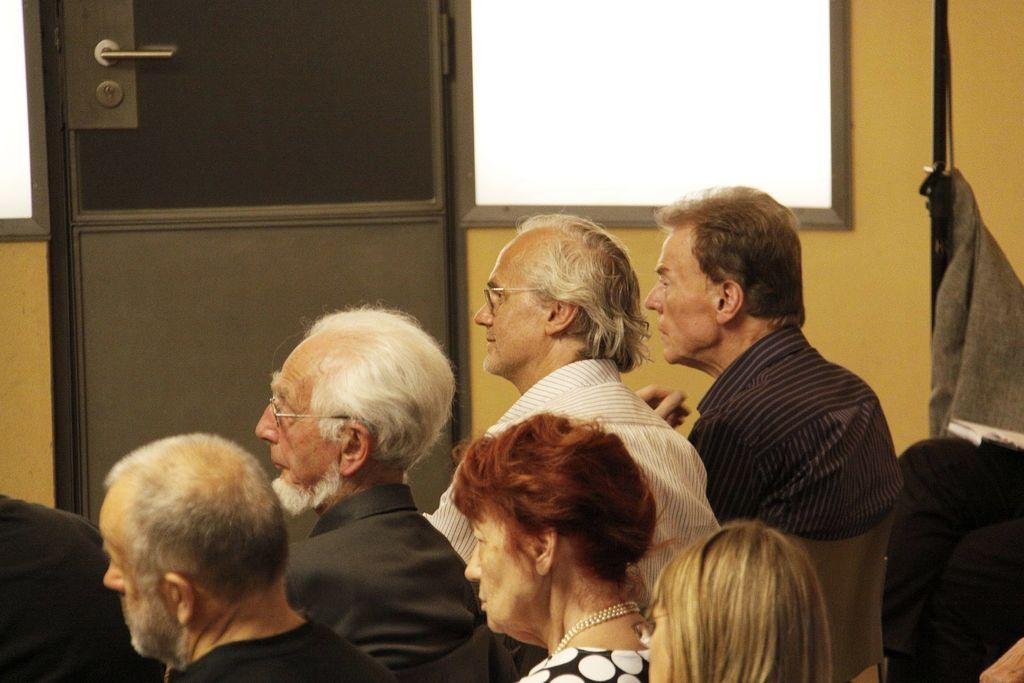What are the people in the image doing? The people in the image are sitting on chairs and watching something. What architectural features can be seen in the image? There are doors and windows visible in the image. Where are the doors and windows located in the image? The doors and windows are on a wall. What type of corn can be seen growing near the people in the image? There is no corn present in the image. Can you tell me how many gloves are visible in the image? There are no gloves visible in the image. 